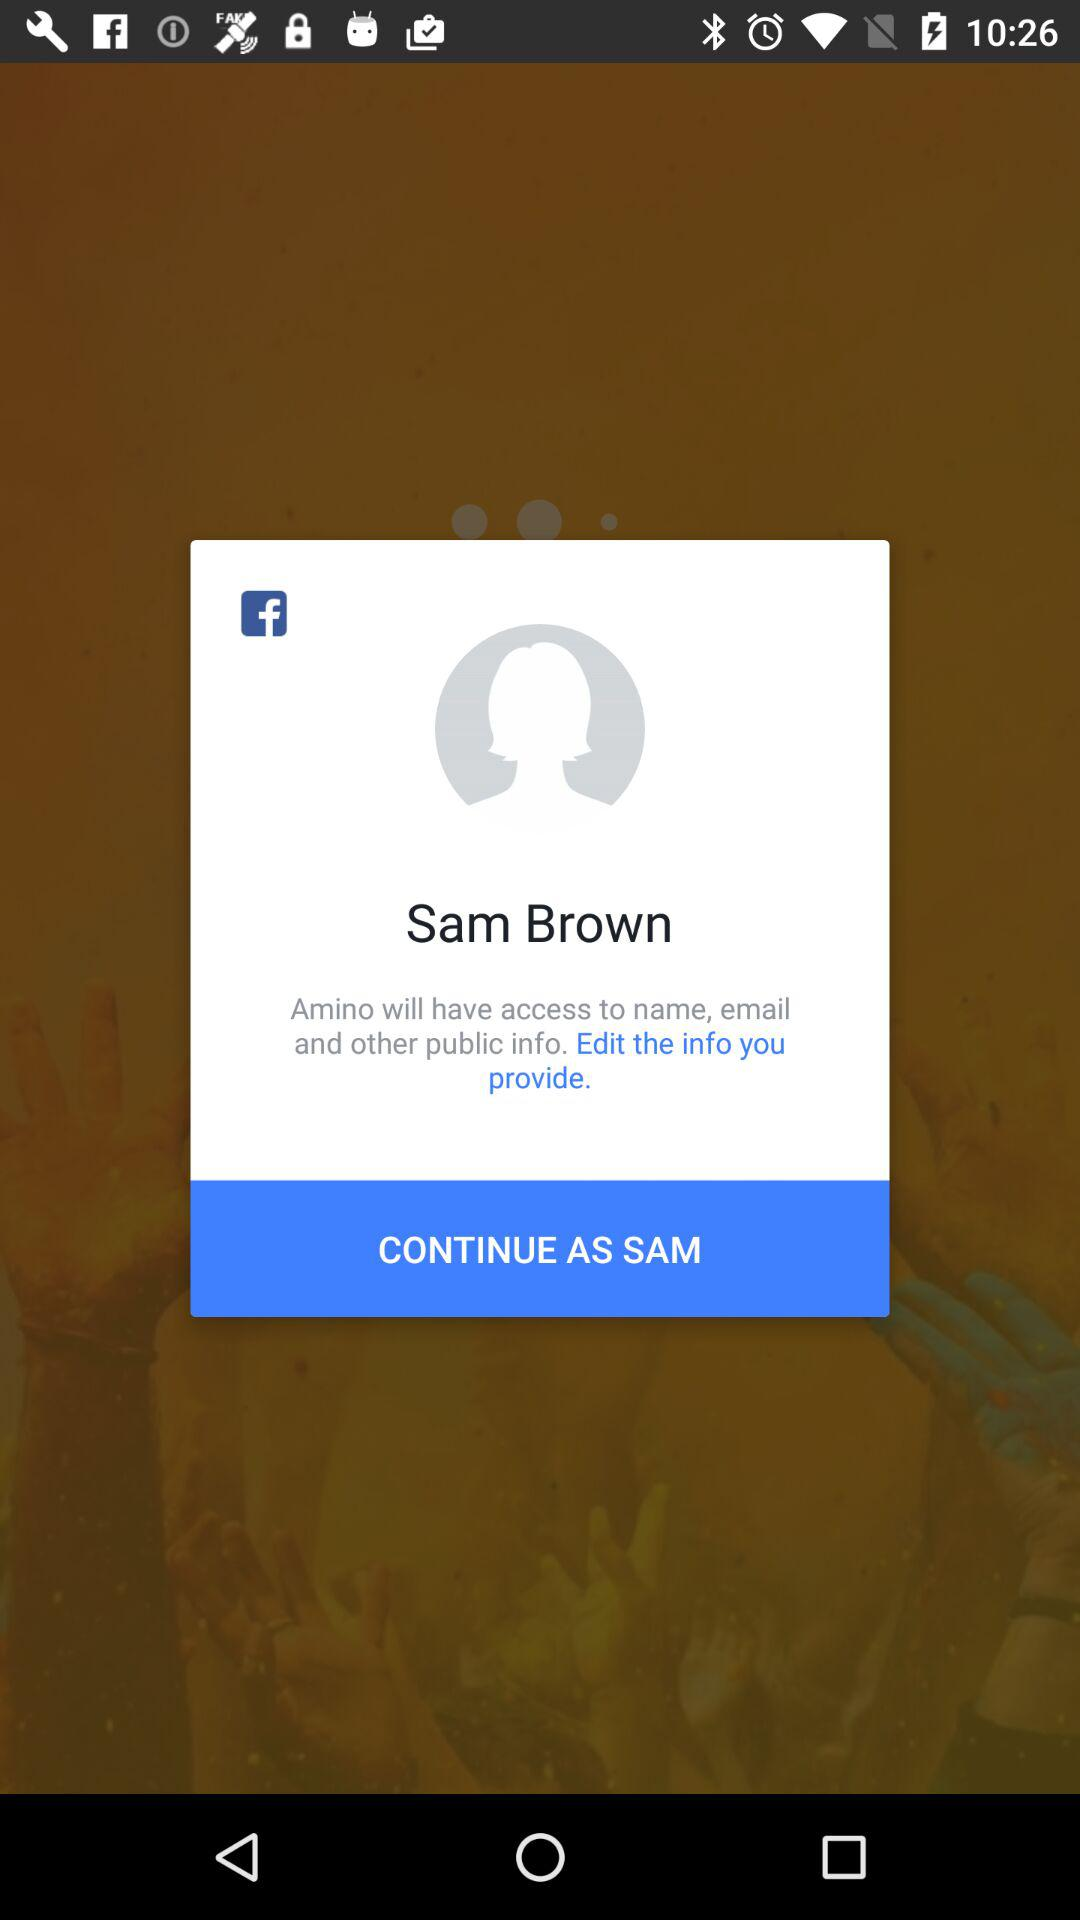What is the login name? The login name is Sam Brown. 